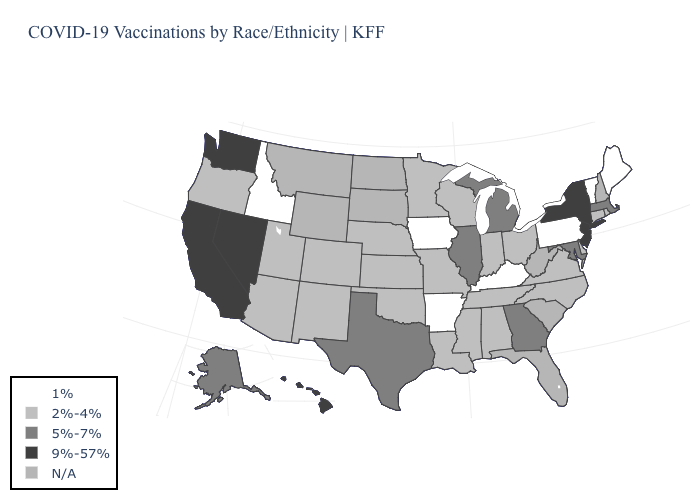Name the states that have a value in the range 1%?
Write a very short answer. Arkansas, Idaho, Iowa, Kentucky, Maine, Pennsylvania, Vermont. Name the states that have a value in the range 2%-4%?
Keep it brief. Alabama, Arizona, Colorado, Connecticut, Delaware, Indiana, Kansas, Louisiana, Minnesota, Mississippi, Missouri, Nebraska, New Mexico, North Carolina, Ohio, Oklahoma, Oregon, Rhode Island, Tennessee, Utah, Virginia, Wisconsin. Name the states that have a value in the range 9%-57%?
Write a very short answer. California, Hawaii, Nevada, New Jersey, New York, Washington. Name the states that have a value in the range 5%-7%?
Be succinct. Alaska, Georgia, Illinois, Maryland, Massachusetts, Michigan, Texas. What is the value of Indiana?
Write a very short answer. 2%-4%. What is the value of Washington?
Be succinct. 9%-57%. Name the states that have a value in the range 1%?
Write a very short answer. Arkansas, Idaho, Iowa, Kentucky, Maine, Pennsylvania, Vermont. What is the lowest value in the South?
Concise answer only. 1%. What is the value of Virginia?
Quick response, please. 2%-4%. What is the lowest value in the USA?
Write a very short answer. 1%. What is the value of New Jersey?
Quick response, please. 9%-57%. Among the states that border Texas , which have the lowest value?
Concise answer only. Arkansas. What is the value of Arkansas?
Concise answer only. 1%. What is the lowest value in the USA?
Short answer required. 1%. What is the value of Pennsylvania?
Short answer required. 1%. 